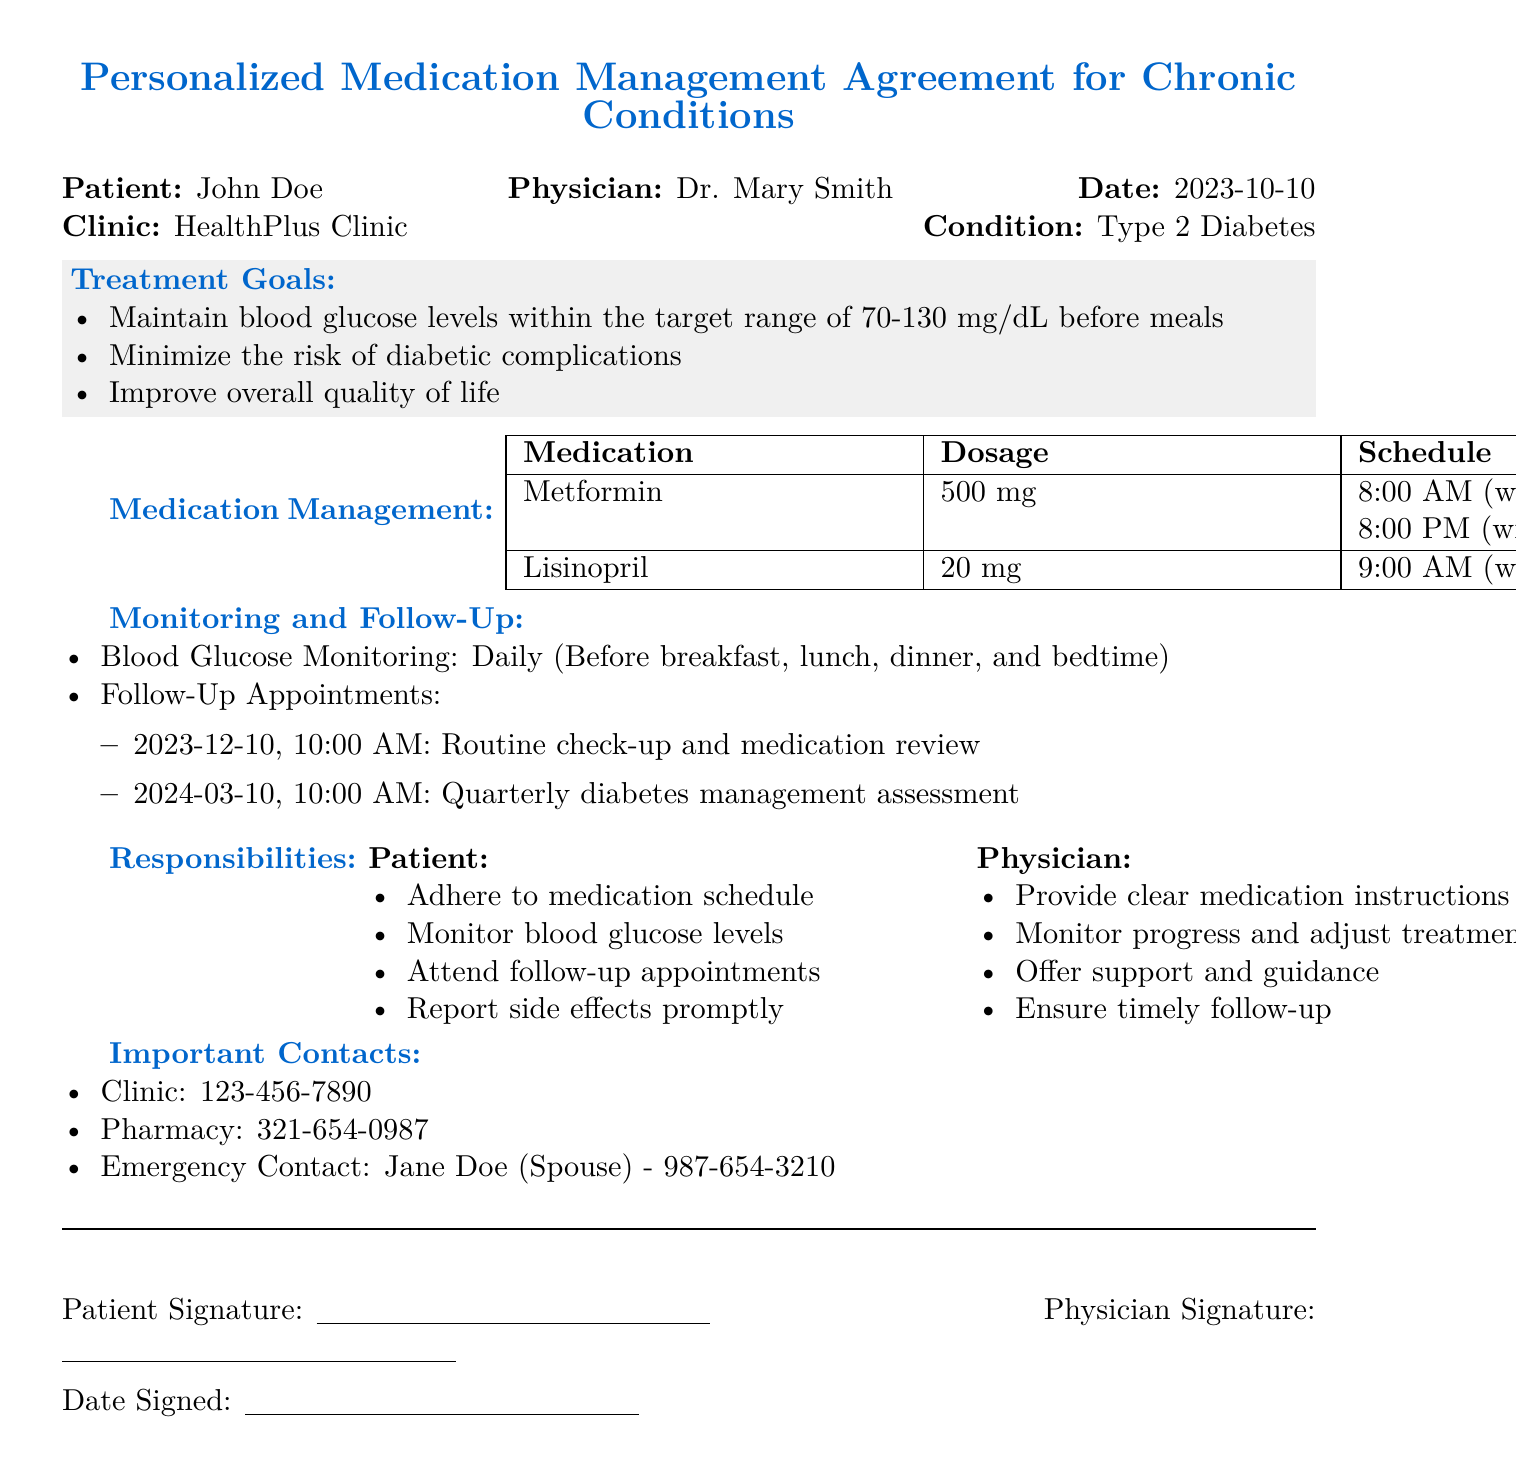What is the patient's name? The patient's name is specified at the top of the document.
Answer: John Doe What is the condition being treated? The condition is stated in the document under the patient's information section.
Answer: Type 2 Diabetes What is the dosage of Lisinopril? The dosage is listed in the medication management table for Lisinopril.
Answer: 20 mg What time is Metformin taken with dinner? The schedule for Metformin indicates the time it should be taken with dinner.
Answer: 8:00 PM What is the date of the first follow-up appointment? The date of the first follow-up appointment is found under the monitoring and follow-up section.
Answer: 2023-12-10 What is one of the treatment goals? Treatment goals are listed in the treatment goals section of the document.
Answer: Maintain blood glucose levels within the target range of 70-130 mg/dL before meals What should the patient report promptly? The responsibilities of the patient include reporting specific concerns that are highlighted in the document.
Answer: Side effects Who is the emergency contact? The emergency contact's information is located in the important contacts section.
Answer: Jane Doe What is the clinic's phone number? The clinic's contact information is provided at the end of the document.
Answer: 123-456-7890 